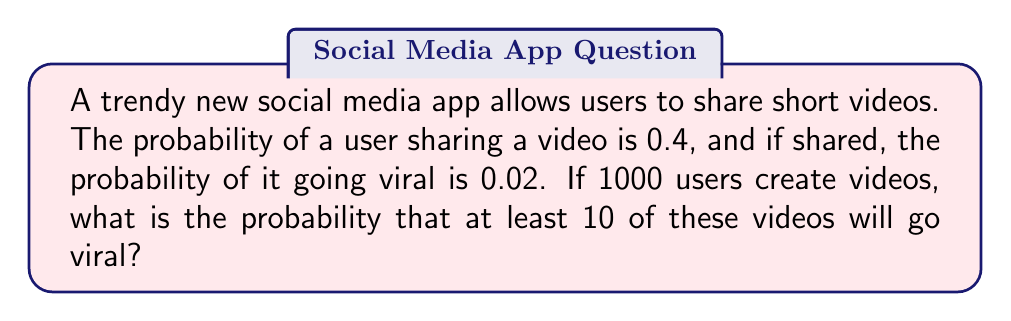What is the answer to this math problem? Let's approach this step-by-step:

1) First, we need to find the probability of a single video going viral. This is a two-step process:
   $P(\text{viral}) = P(\text{shared}) \times P(\text{viral | shared}) = 0.4 \times 0.02 = 0.008$

2) Now, we have a situation where we're looking for at least 10 successes (viral videos) out of 1000 trials, each with a probability of 0.008. This follows a binomial distribution.

3) The probability of at least 10 viral videos is equal to 1 minus the probability of 9 or fewer viral videos:

   $P(X \geq 10) = 1 - P(X \leq 9)$

   where $X$ is the number of viral videos.

4) We can calculate this using the cumulative binomial probability function:

   $P(X \geq 10) = 1 - \sum_{k=0}^{9} \binom{1000}{k} (0.008)^k (0.992)^{1000-k}$

5) This is a complex calculation, best done with statistical software or a calculator with binomial probability functions. Using such a tool, we get:

   $P(X \geq 10) \approx 0.9989$

Therefore, the probability that at least 10 videos will go viral is approximately 0.9989 or 99.89%.
Answer: 0.9989 